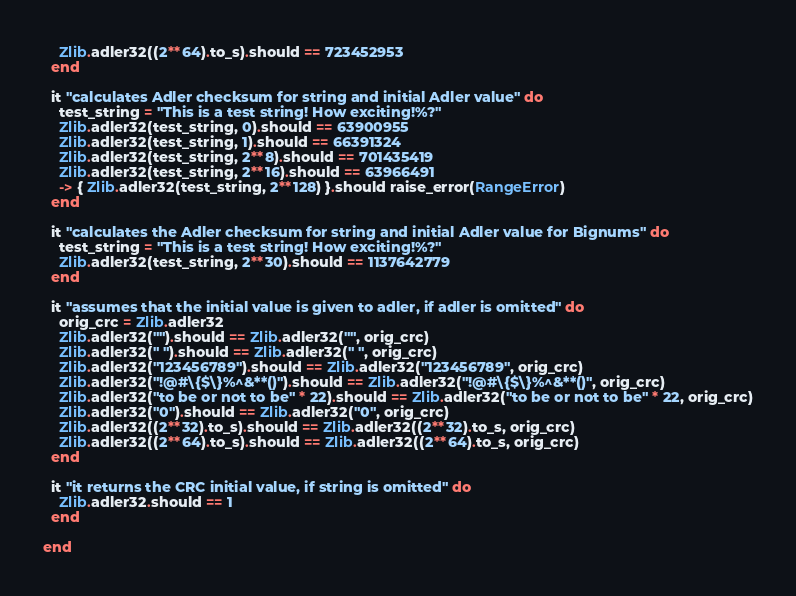<code> <loc_0><loc_0><loc_500><loc_500><_Ruby_>    Zlib.adler32((2**64).to_s).should == 723452953
  end

  it "calculates Adler checksum for string and initial Adler value" do
    test_string = "This is a test string! How exciting!%?"
    Zlib.adler32(test_string, 0).should == 63900955
    Zlib.adler32(test_string, 1).should == 66391324
    Zlib.adler32(test_string, 2**8).should == 701435419
    Zlib.adler32(test_string, 2**16).should == 63966491
    -> { Zlib.adler32(test_string, 2**128) }.should raise_error(RangeError)
  end

  it "calculates the Adler checksum for string and initial Adler value for Bignums" do
    test_string = "This is a test string! How exciting!%?"
    Zlib.adler32(test_string, 2**30).should == 1137642779
  end

  it "assumes that the initial value is given to adler, if adler is omitted" do
    orig_crc = Zlib.adler32
    Zlib.adler32("").should == Zlib.adler32("", orig_crc)
    Zlib.adler32(" ").should == Zlib.adler32(" ", orig_crc)
    Zlib.adler32("123456789").should == Zlib.adler32("123456789", orig_crc)
    Zlib.adler32("!@#\{$\}%^&**()").should == Zlib.adler32("!@#\{$\}%^&**()", orig_crc)
    Zlib.adler32("to be or not to be" * 22).should == Zlib.adler32("to be or not to be" * 22, orig_crc)
    Zlib.adler32("0").should == Zlib.adler32("0", orig_crc)
    Zlib.adler32((2**32).to_s).should == Zlib.adler32((2**32).to_s, orig_crc)
    Zlib.adler32((2**64).to_s).should == Zlib.adler32((2**64).to_s, orig_crc)
  end

  it "it returns the CRC initial value, if string is omitted" do
    Zlib.adler32.should == 1
  end

end
</code> 